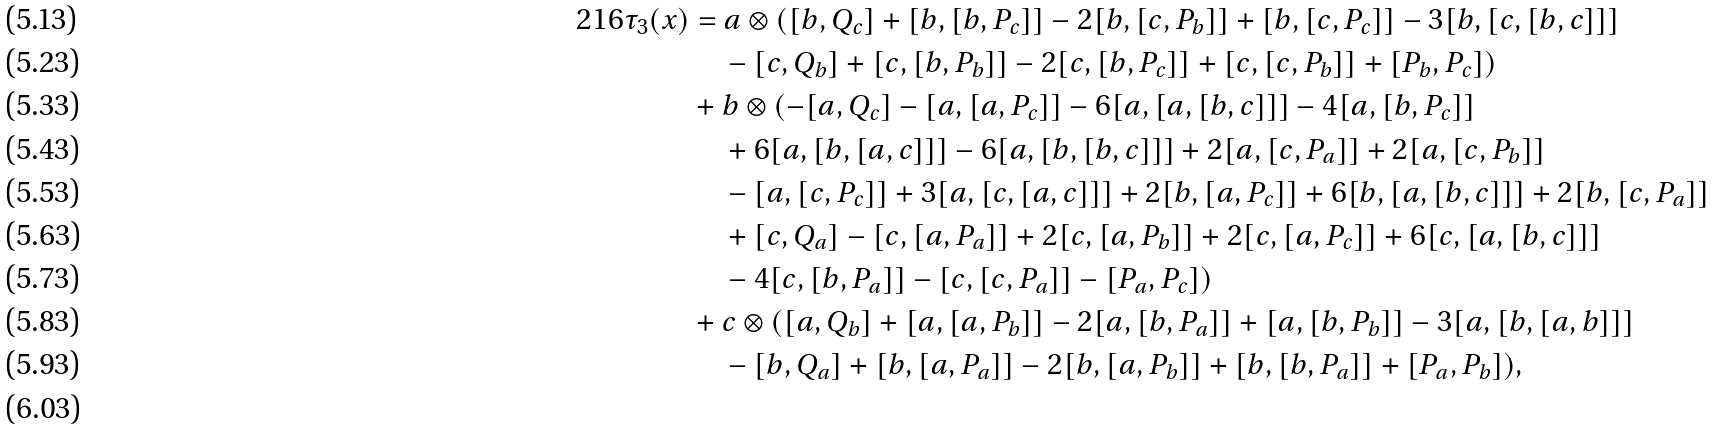Convert formula to latex. <formula><loc_0><loc_0><loc_500><loc_500>2 1 6 \tau _ { 3 } ( x ) & = a \otimes ( [ b , Q _ { c } ] + [ b , [ b , P _ { c } ] ] - 2 [ b , [ c , P _ { b } ] ] + [ b , [ c , P _ { c } ] ] - 3 [ b , [ c , [ b , c ] ] ] \\ & \quad - [ c , Q _ { b } ] + [ c , [ b , P _ { b } ] ] - 2 [ c , [ b , P _ { c } ] ] + [ c , [ c , P _ { b } ] ] + [ P _ { b } , P _ { c } ] ) \\ & + b \otimes ( - [ a , Q _ { c } ] - [ a , [ a , P _ { c } ] ] - 6 [ a , [ a , [ b , c ] ] ] - 4 [ a , [ b , P _ { c } ] ] \\ & \quad + 6 [ a , [ b , [ a , c ] ] ] - 6 [ a , [ b , [ b , c ] ] ] + 2 [ a , [ c , P _ { a } ] ] + 2 [ a , [ c , P _ { b } ] ] \\ & \quad - [ a , [ c , P _ { c } ] ] + 3 [ a , [ c , [ a , c ] ] ] + 2 [ b , [ a , P _ { c } ] ] + 6 [ b , [ a , [ b , c ] ] ] + 2 [ b , [ c , P _ { a } ] ] \\ & \quad + [ c , Q _ { a } ] - [ c , [ a , P _ { a } ] ] + 2 [ c , [ a , P _ { b } ] ] + 2 [ c , [ a , P _ { c } ] ] + 6 [ c , [ a , [ b , c ] ] ] \\ & \quad - 4 [ c , [ b , P _ { a } ] ] - [ c , [ c , P _ { a } ] ] - [ P _ { a } , P _ { c } ] ) \\ & + c \otimes ( [ a , Q _ { b } ] + [ a , [ a , P _ { b } ] ] - 2 [ a , [ b , P _ { a } ] ] + [ a , [ b , P _ { b } ] ] - 3 [ a , [ b , [ a , b ] ] ] \\ & \quad - [ b , Q _ { a } ] + [ b , [ a , P _ { a } ] ] - 2 [ b , [ a , P _ { b } ] ] + [ b , [ b , P _ { a } ] ] + [ P _ { a } , P _ { b } ] ) , \\</formula> 